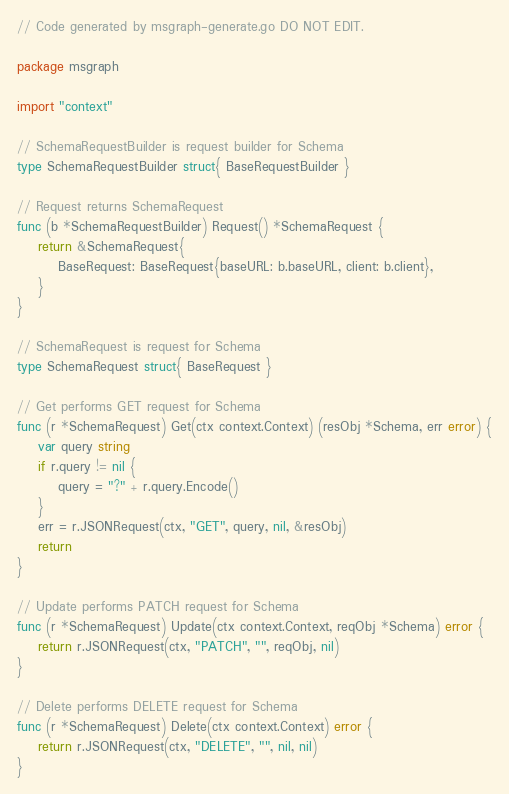Convert code to text. <code><loc_0><loc_0><loc_500><loc_500><_Go_>// Code generated by msgraph-generate.go DO NOT EDIT.

package msgraph

import "context"

// SchemaRequestBuilder is request builder for Schema
type SchemaRequestBuilder struct{ BaseRequestBuilder }

// Request returns SchemaRequest
func (b *SchemaRequestBuilder) Request() *SchemaRequest {
	return &SchemaRequest{
		BaseRequest: BaseRequest{baseURL: b.baseURL, client: b.client},
	}
}

// SchemaRequest is request for Schema
type SchemaRequest struct{ BaseRequest }

// Get performs GET request for Schema
func (r *SchemaRequest) Get(ctx context.Context) (resObj *Schema, err error) {
	var query string
	if r.query != nil {
		query = "?" + r.query.Encode()
	}
	err = r.JSONRequest(ctx, "GET", query, nil, &resObj)
	return
}

// Update performs PATCH request for Schema
func (r *SchemaRequest) Update(ctx context.Context, reqObj *Schema) error {
	return r.JSONRequest(ctx, "PATCH", "", reqObj, nil)
}

// Delete performs DELETE request for Schema
func (r *SchemaRequest) Delete(ctx context.Context) error {
	return r.JSONRequest(ctx, "DELETE", "", nil, nil)
}
</code> 